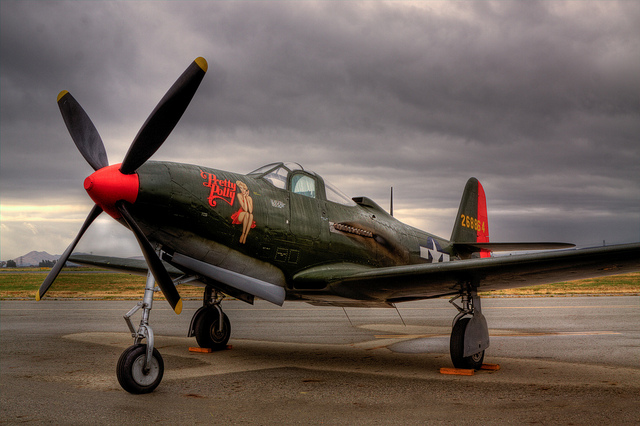Identify and read out the text in this image. Polly Hetty 